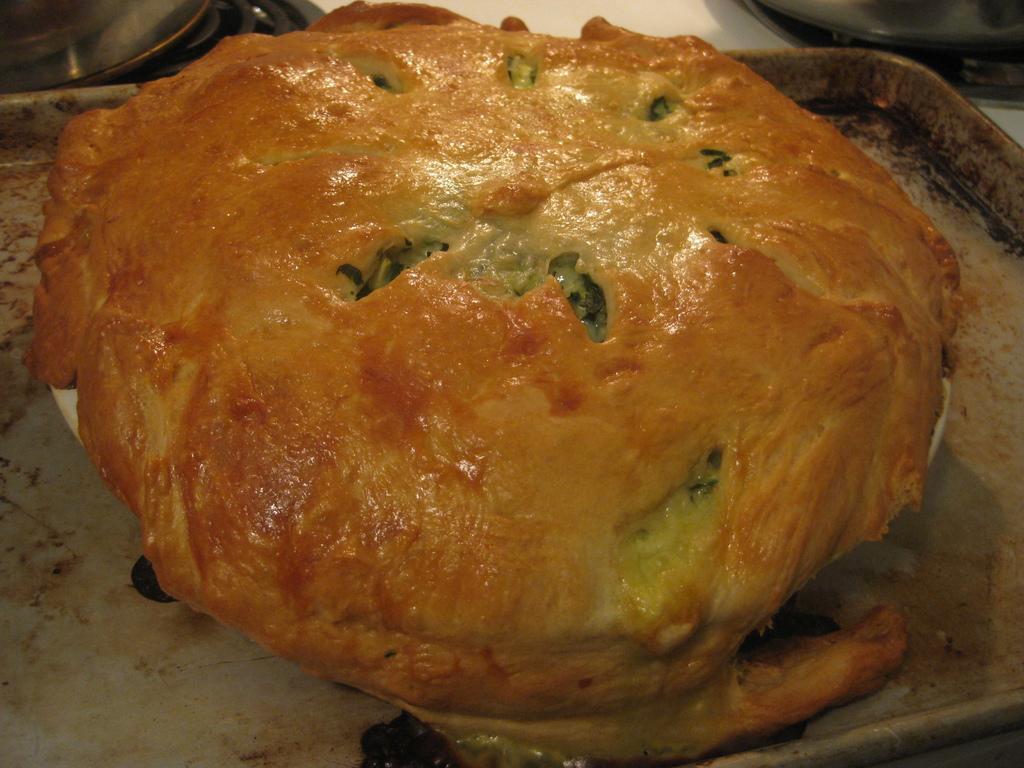Can you describe this image briefly? At the bottom of the image there is a table and we can see a food item, tray, bowls and plates placed on the table. 